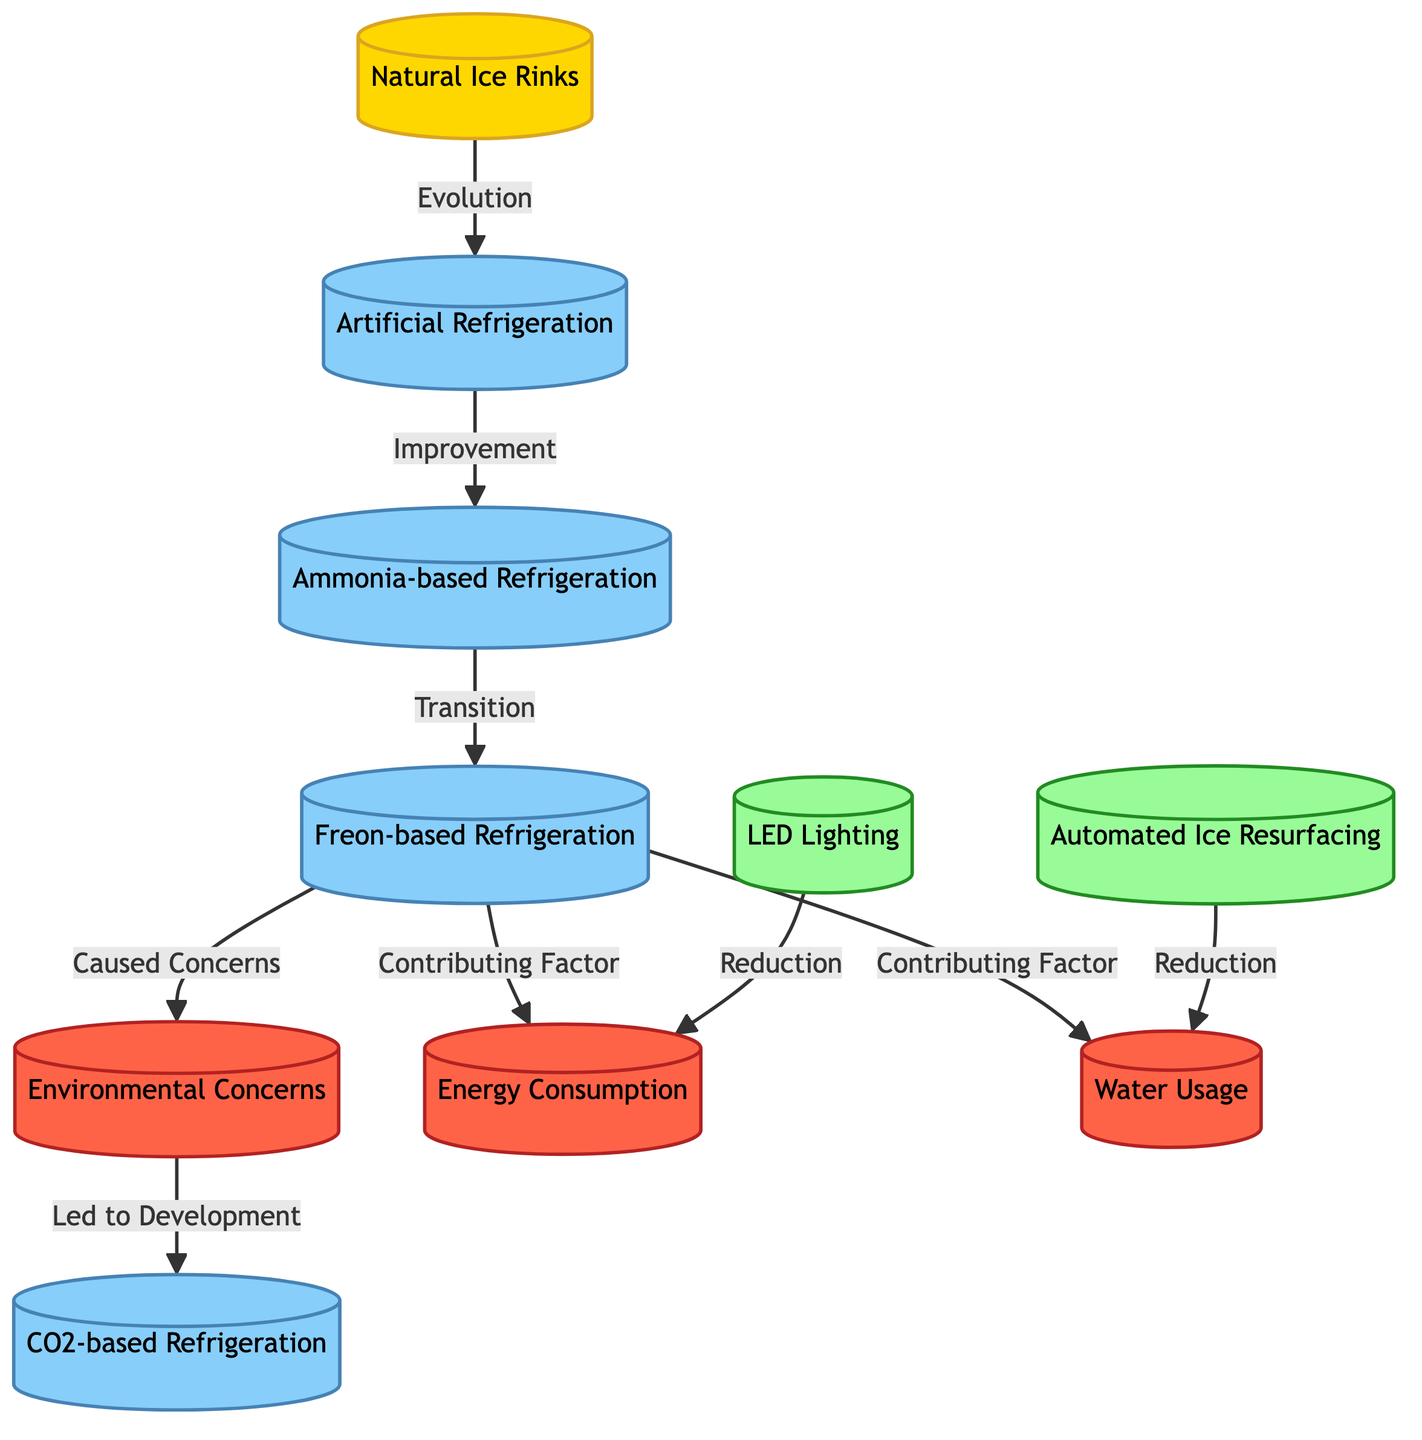What is the first type of ice rink referenced in the diagram? The diagram starts with the first node labeled "Natural Ice Rinks," indicating it as the origin of the evolution.
Answer: Natural Ice Rinks What type of refrigeration followed artificial refrigeration in the evolution? The flow from the second node indicates that the next type is "Ammonia-based Refrigeration," which directly follows the initial "Artificial Refrigeration."
Answer: Ammonia-based Refrigeration How many types of refrigeration technologies are mentioned in the diagram? The diagram lists four types of refrigeration technologies: "Artificial Refrigeration," "Ammonia-based Refrigeration," "Freon-based Refrigeration," and "CO2-based Refrigeration."
Answer: Four What caused environmental concerns according to the diagram? The diagram states that "Freon-based Refrigeration" is the node that "Caused Concerns," linking the technology to environmental issues.
Answer: Freon-based Refrigeration Which advancements are linked to the reduction of energy consumption? The diagram shows "LED Lighting" as an advancement that leads to a reduction in energy consumption, connecting its benefits to the environmental impact.
Answer: LED Lighting What two factors contribute to the environmental impact related to Freon-based Refrigeration? The diagram indicates that "Energy Consumption" and "Water Usage" are both factors contributed by "Freon-based Refrigeration."
Answer: Energy Consumption, Water Usage What technology developed as a response to concerns caused by Freon-based refrigeration? The flow leads from "Environmental Concerns" to "CO2-based Refrigeration," indicating that this technology was developed in response to those concerns.
Answer: CO2-based Refrigeration How do automated ice resurfacing and LED lighting affect water usage? Both advancements connect to a reduction in water usage; following the nodes shows they contribute to decreasing environmental impacts, addressing the concerns raised by earlier technologies.
Answer: Reduction Which node is linked to both energy consumption and water usage? The node "Freon-based Refrigeration" branches out to both "Energy Consumption" and "Water Usage," indicating its impact on both environmental aspects.
Answer: Freon-based Refrigeration 